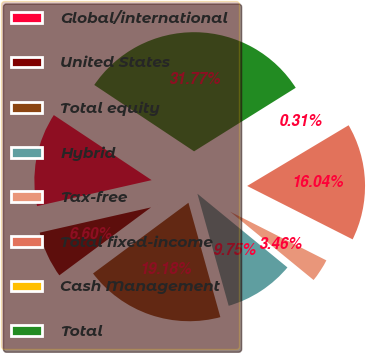Convert chart. <chart><loc_0><loc_0><loc_500><loc_500><pie_chart><fcel>Global/international<fcel>United States<fcel>Total equity<fcel>Hybrid<fcel>Tax-free<fcel>Total fixed-income<fcel>Cash Management<fcel>Total<nl><fcel>12.89%<fcel>6.6%<fcel>19.18%<fcel>9.75%<fcel>3.46%<fcel>16.04%<fcel>0.31%<fcel>31.77%<nl></chart> 